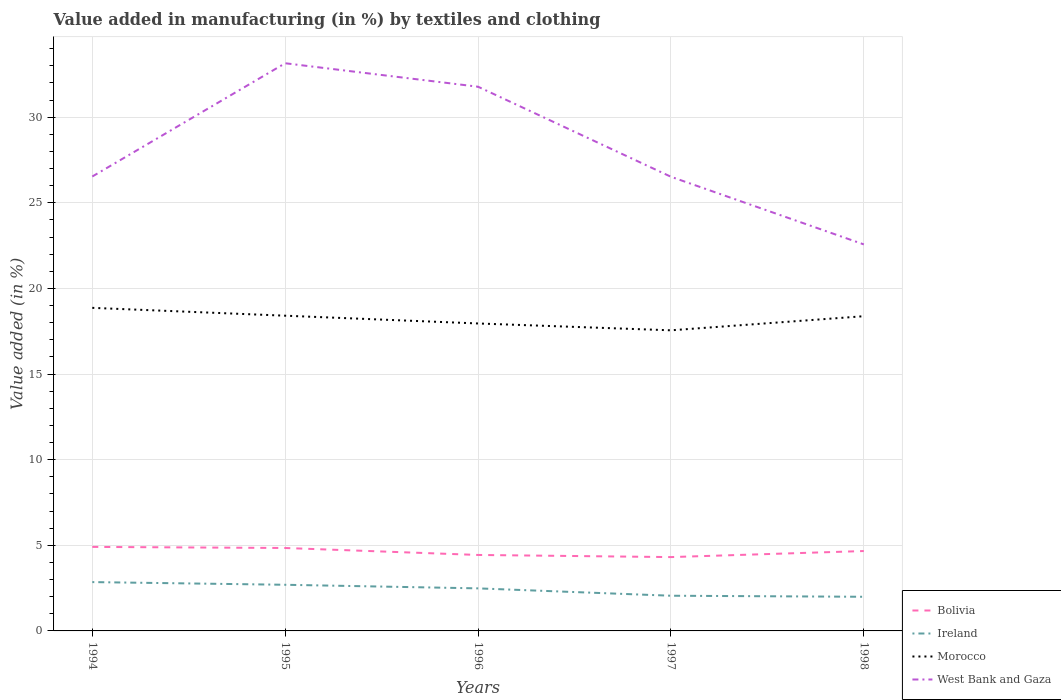How many different coloured lines are there?
Make the answer very short. 4. Does the line corresponding to Morocco intersect with the line corresponding to West Bank and Gaza?
Your answer should be compact. No. Across all years, what is the maximum percentage of value added in manufacturing by textiles and clothing in Morocco?
Keep it short and to the point. 17.56. What is the total percentage of value added in manufacturing by textiles and clothing in Bolivia in the graph?
Your answer should be very brief. 0.18. What is the difference between the highest and the second highest percentage of value added in manufacturing by textiles and clothing in Ireland?
Your answer should be compact. 0.86. What is the difference between the highest and the lowest percentage of value added in manufacturing by textiles and clothing in West Bank and Gaza?
Keep it short and to the point. 2. Is the percentage of value added in manufacturing by textiles and clothing in Bolivia strictly greater than the percentage of value added in manufacturing by textiles and clothing in Morocco over the years?
Your response must be concise. Yes. How many years are there in the graph?
Your answer should be compact. 5. What is the title of the graph?
Your answer should be very brief. Value added in manufacturing (in %) by textiles and clothing. Does "Timor-Leste" appear as one of the legend labels in the graph?
Keep it short and to the point. No. What is the label or title of the Y-axis?
Give a very brief answer. Value added (in %). What is the Value added (in %) in Bolivia in 1994?
Provide a short and direct response. 4.91. What is the Value added (in %) of Ireland in 1994?
Offer a very short reply. 2.85. What is the Value added (in %) of Morocco in 1994?
Provide a succinct answer. 18.87. What is the Value added (in %) in West Bank and Gaza in 1994?
Provide a succinct answer. 26.54. What is the Value added (in %) in Bolivia in 1995?
Your response must be concise. 4.84. What is the Value added (in %) of Ireland in 1995?
Give a very brief answer. 2.69. What is the Value added (in %) in Morocco in 1995?
Keep it short and to the point. 18.41. What is the Value added (in %) in West Bank and Gaza in 1995?
Keep it short and to the point. 33.15. What is the Value added (in %) of Bolivia in 1996?
Give a very brief answer. 4.44. What is the Value added (in %) of Ireland in 1996?
Offer a terse response. 2.49. What is the Value added (in %) in Morocco in 1996?
Make the answer very short. 17.96. What is the Value added (in %) in West Bank and Gaza in 1996?
Provide a short and direct response. 31.78. What is the Value added (in %) in Bolivia in 1997?
Provide a short and direct response. 4.31. What is the Value added (in %) in Ireland in 1997?
Give a very brief answer. 2.06. What is the Value added (in %) of Morocco in 1997?
Make the answer very short. 17.56. What is the Value added (in %) in West Bank and Gaza in 1997?
Your answer should be compact. 26.52. What is the Value added (in %) of Bolivia in 1998?
Your answer should be compact. 4.67. What is the Value added (in %) of Ireland in 1998?
Keep it short and to the point. 1.99. What is the Value added (in %) of Morocco in 1998?
Ensure brevity in your answer.  18.38. What is the Value added (in %) in West Bank and Gaza in 1998?
Your answer should be very brief. 22.57. Across all years, what is the maximum Value added (in %) of Bolivia?
Your response must be concise. 4.91. Across all years, what is the maximum Value added (in %) of Ireland?
Your answer should be compact. 2.85. Across all years, what is the maximum Value added (in %) of Morocco?
Your answer should be compact. 18.87. Across all years, what is the maximum Value added (in %) in West Bank and Gaza?
Make the answer very short. 33.15. Across all years, what is the minimum Value added (in %) in Bolivia?
Offer a very short reply. 4.31. Across all years, what is the minimum Value added (in %) of Ireland?
Your answer should be compact. 1.99. Across all years, what is the minimum Value added (in %) in Morocco?
Keep it short and to the point. 17.56. Across all years, what is the minimum Value added (in %) in West Bank and Gaza?
Provide a short and direct response. 22.57. What is the total Value added (in %) of Bolivia in the graph?
Make the answer very short. 23.16. What is the total Value added (in %) of Ireland in the graph?
Your answer should be very brief. 12.08. What is the total Value added (in %) in Morocco in the graph?
Make the answer very short. 91.17. What is the total Value added (in %) in West Bank and Gaza in the graph?
Your answer should be compact. 140.57. What is the difference between the Value added (in %) of Bolivia in 1994 and that in 1995?
Offer a terse response. 0.06. What is the difference between the Value added (in %) in Ireland in 1994 and that in 1995?
Your response must be concise. 0.16. What is the difference between the Value added (in %) in Morocco in 1994 and that in 1995?
Provide a short and direct response. 0.46. What is the difference between the Value added (in %) in West Bank and Gaza in 1994 and that in 1995?
Provide a succinct answer. -6.62. What is the difference between the Value added (in %) in Bolivia in 1994 and that in 1996?
Make the answer very short. 0.47. What is the difference between the Value added (in %) in Ireland in 1994 and that in 1996?
Ensure brevity in your answer.  0.37. What is the difference between the Value added (in %) of Morocco in 1994 and that in 1996?
Offer a terse response. 0.91. What is the difference between the Value added (in %) in West Bank and Gaza in 1994 and that in 1996?
Keep it short and to the point. -5.24. What is the difference between the Value added (in %) in Bolivia in 1994 and that in 1997?
Give a very brief answer. 0.6. What is the difference between the Value added (in %) in Ireland in 1994 and that in 1997?
Give a very brief answer. 0.8. What is the difference between the Value added (in %) in Morocco in 1994 and that in 1997?
Provide a short and direct response. 1.31. What is the difference between the Value added (in %) in West Bank and Gaza in 1994 and that in 1997?
Make the answer very short. 0.01. What is the difference between the Value added (in %) in Bolivia in 1994 and that in 1998?
Your answer should be compact. 0.24. What is the difference between the Value added (in %) in Ireland in 1994 and that in 1998?
Keep it short and to the point. 0.86. What is the difference between the Value added (in %) of Morocco in 1994 and that in 1998?
Provide a short and direct response. 0.49. What is the difference between the Value added (in %) of West Bank and Gaza in 1994 and that in 1998?
Provide a short and direct response. 3.97. What is the difference between the Value added (in %) of Bolivia in 1995 and that in 1996?
Offer a terse response. 0.41. What is the difference between the Value added (in %) in Ireland in 1995 and that in 1996?
Provide a short and direct response. 0.21. What is the difference between the Value added (in %) of Morocco in 1995 and that in 1996?
Provide a short and direct response. 0.45. What is the difference between the Value added (in %) in West Bank and Gaza in 1995 and that in 1996?
Your answer should be very brief. 1.37. What is the difference between the Value added (in %) of Bolivia in 1995 and that in 1997?
Provide a short and direct response. 0.53. What is the difference between the Value added (in %) in Ireland in 1995 and that in 1997?
Your response must be concise. 0.64. What is the difference between the Value added (in %) in Morocco in 1995 and that in 1997?
Your answer should be compact. 0.85. What is the difference between the Value added (in %) of West Bank and Gaza in 1995 and that in 1997?
Keep it short and to the point. 6.63. What is the difference between the Value added (in %) in Bolivia in 1995 and that in 1998?
Make the answer very short. 0.18. What is the difference between the Value added (in %) in Ireland in 1995 and that in 1998?
Your response must be concise. 0.7. What is the difference between the Value added (in %) of Morocco in 1995 and that in 1998?
Make the answer very short. 0.03. What is the difference between the Value added (in %) of West Bank and Gaza in 1995 and that in 1998?
Ensure brevity in your answer.  10.58. What is the difference between the Value added (in %) of Bolivia in 1996 and that in 1997?
Give a very brief answer. 0.12. What is the difference between the Value added (in %) in Ireland in 1996 and that in 1997?
Give a very brief answer. 0.43. What is the difference between the Value added (in %) of Morocco in 1996 and that in 1997?
Keep it short and to the point. 0.4. What is the difference between the Value added (in %) in West Bank and Gaza in 1996 and that in 1997?
Your response must be concise. 5.26. What is the difference between the Value added (in %) in Bolivia in 1996 and that in 1998?
Give a very brief answer. -0.23. What is the difference between the Value added (in %) of Ireland in 1996 and that in 1998?
Give a very brief answer. 0.49. What is the difference between the Value added (in %) in Morocco in 1996 and that in 1998?
Ensure brevity in your answer.  -0.42. What is the difference between the Value added (in %) of West Bank and Gaza in 1996 and that in 1998?
Your answer should be very brief. 9.21. What is the difference between the Value added (in %) in Bolivia in 1997 and that in 1998?
Provide a short and direct response. -0.35. What is the difference between the Value added (in %) of Ireland in 1997 and that in 1998?
Your answer should be very brief. 0.06. What is the difference between the Value added (in %) of Morocco in 1997 and that in 1998?
Offer a terse response. -0.82. What is the difference between the Value added (in %) of West Bank and Gaza in 1997 and that in 1998?
Ensure brevity in your answer.  3.95. What is the difference between the Value added (in %) of Bolivia in 1994 and the Value added (in %) of Ireland in 1995?
Your answer should be very brief. 2.21. What is the difference between the Value added (in %) of Bolivia in 1994 and the Value added (in %) of Morocco in 1995?
Your answer should be very brief. -13.5. What is the difference between the Value added (in %) of Bolivia in 1994 and the Value added (in %) of West Bank and Gaza in 1995?
Offer a very short reply. -28.25. What is the difference between the Value added (in %) of Ireland in 1994 and the Value added (in %) of Morocco in 1995?
Your answer should be very brief. -15.56. What is the difference between the Value added (in %) in Ireland in 1994 and the Value added (in %) in West Bank and Gaza in 1995?
Your answer should be very brief. -30.3. What is the difference between the Value added (in %) in Morocco in 1994 and the Value added (in %) in West Bank and Gaza in 1995?
Give a very brief answer. -14.28. What is the difference between the Value added (in %) in Bolivia in 1994 and the Value added (in %) in Ireland in 1996?
Provide a succinct answer. 2.42. What is the difference between the Value added (in %) in Bolivia in 1994 and the Value added (in %) in Morocco in 1996?
Your response must be concise. -13.05. What is the difference between the Value added (in %) in Bolivia in 1994 and the Value added (in %) in West Bank and Gaza in 1996?
Provide a short and direct response. -26.87. What is the difference between the Value added (in %) of Ireland in 1994 and the Value added (in %) of Morocco in 1996?
Your answer should be very brief. -15.1. What is the difference between the Value added (in %) of Ireland in 1994 and the Value added (in %) of West Bank and Gaza in 1996?
Offer a very short reply. -28.93. What is the difference between the Value added (in %) of Morocco in 1994 and the Value added (in %) of West Bank and Gaza in 1996?
Make the answer very short. -12.91. What is the difference between the Value added (in %) in Bolivia in 1994 and the Value added (in %) in Ireland in 1997?
Provide a short and direct response. 2.85. What is the difference between the Value added (in %) of Bolivia in 1994 and the Value added (in %) of Morocco in 1997?
Make the answer very short. -12.65. What is the difference between the Value added (in %) of Bolivia in 1994 and the Value added (in %) of West Bank and Gaza in 1997?
Ensure brevity in your answer.  -21.62. What is the difference between the Value added (in %) of Ireland in 1994 and the Value added (in %) of Morocco in 1997?
Keep it short and to the point. -14.7. What is the difference between the Value added (in %) of Ireland in 1994 and the Value added (in %) of West Bank and Gaza in 1997?
Your response must be concise. -23.67. What is the difference between the Value added (in %) of Morocco in 1994 and the Value added (in %) of West Bank and Gaza in 1997?
Offer a very short reply. -7.66. What is the difference between the Value added (in %) of Bolivia in 1994 and the Value added (in %) of Ireland in 1998?
Your answer should be compact. 2.91. What is the difference between the Value added (in %) in Bolivia in 1994 and the Value added (in %) in Morocco in 1998?
Give a very brief answer. -13.47. What is the difference between the Value added (in %) of Bolivia in 1994 and the Value added (in %) of West Bank and Gaza in 1998?
Your response must be concise. -17.67. What is the difference between the Value added (in %) in Ireland in 1994 and the Value added (in %) in Morocco in 1998?
Your answer should be very brief. -15.53. What is the difference between the Value added (in %) in Ireland in 1994 and the Value added (in %) in West Bank and Gaza in 1998?
Make the answer very short. -19.72. What is the difference between the Value added (in %) in Morocco in 1994 and the Value added (in %) in West Bank and Gaza in 1998?
Offer a terse response. -3.7. What is the difference between the Value added (in %) in Bolivia in 1995 and the Value added (in %) in Ireland in 1996?
Make the answer very short. 2.36. What is the difference between the Value added (in %) in Bolivia in 1995 and the Value added (in %) in Morocco in 1996?
Provide a short and direct response. -13.11. What is the difference between the Value added (in %) in Bolivia in 1995 and the Value added (in %) in West Bank and Gaza in 1996?
Offer a terse response. -26.94. What is the difference between the Value added (in %) of Ireland in 1995 and the Value added (in %) of Morocco in 1996?
Ensure brevity in your answer.  -15.26. What is the difference between the Value added (in %) of Ireland in 1995 and the Value added (in %) of West Bank and Gaza in 1996?
Provide a short and direct response. -29.09. What is the difference between the Value added (in %) in Morocco in 1995 and the Value added (in %) in West Bank and Gaza in 1996?
Provide a short and direct response. -13.37. What is the difference between the Value added (in %) of Bolivia in 1995 and the Value added (in %) of Ireland in 1997?
Keep it short and to the point. 2.79. What is the difference between the Value added (in %) of Bolivia in 1995 and the Value added (in %) of Morocco in 1997?
Offer a very short reply. -12.71. What is the difference between the Value added (in %) in Bolivia in 1995 and the Value added (in %) in West Bank and Gaza in 1997?
Offer a very short reply. -21.68. What is the difference between the Value added (in %) of Ireland in 1995 and the Value added (in %) of Morocco in 1997?
Ensure brevity in your answer.  -14.86. What is the difference between the Value added (in %) in Ireland in 1995 and the Value added (in %) in West Bank and Gaza in 1997?
Your answer should be compact. -23.83. What is the difference between the Value added (in %) in Morocco in 1995 and the Value added (in %) in West Bank and Gaza in 1997?
Provide a succinct answer. -8.11. What is the difference between the Value added (in %) of Bolivia in 1995 and the Value added (in %) of Ireland in 1998?
Make the answer very short. 2.85. What is the difference between the Value added (in %) of Bolivia in 1995 and the Value added (in %) of Morocco in 1998?
Your answer should be very brief. -13.54. What is the difference between the Value added (in %) of Bolivia in 1995 and the Value added (in %) of West Bank and Gaza in 1998?
Make the answer very short. -17.73. What is the difference between the Value added (in %) in Ireland in 1995 and the Value added (in %) in Morocco in 1998?
Offer a terse response. -15.69. What is the difference between the Value added (in %) in Ireland in 1995 and the Value added (in %) in West Bank and Gaza in 1998?
Provide a short and direct response. -19.88. What is the difference between the Value added (in %) in Morocco in 1995 and the Value added (in %) in West Bank and Gaza in 1998?
Your answer should be very brief. -4.16. What is the difference between the Value added (in %) in Bolivia in 1996 and the Value added (in %) in Ireland in 1997?
Offer a terse response. 2.38. What is the difference between the Value added (in %) in Bolivia in 1996 and the Value added (in %) in Morocco in 1997?
Give a very brief answer. -13.12. What is the difference between the Value added (in %) of Bolivia in 1996 and the Value added (in %) of West Bank and Gaza in 1997?
Ensure brevity in your answer.  -22.09. What is the difference between the Value added (in %) of Ireland in 1996 and the Value added (in %) of Morocco in 1997?
Provide a succinct answer. -15.07. What is the difference between the Value added (in %) of Ireland in 1996 and the Value added (in %) of West Bank and Gaza in 1997?
Make the answer very short. -24.04. What is the difference between the Value added (in %) in Morocco in 1996 and the Value added (in %) in West Bank and Gaza in 1997?
Provide a succinct answer. -8.57. What is the difference between the Value added (in %) in Bolivia in 1996 and the Value added (in %) in Ireland in 1998?
Your answer should be compact. 2.44. What is the difference between the Value added (in %) in Bolivia in 1996 and the Value added (in %) in Morocco in 1998?
Offer a terse response. -13.94. What is the difference between the Value added (in %) in Bolivia in 1996 and the Value added (in %) in West Bank and Gaza in 1998?
Ensure brevity in your answer.  -18.14. What is the difference between the Value added (in %) in Ireland in 1996 and the Value added (in %) in Morocco in 1998?
Make the answer very short. -15.9. What is the difference between the Value added (in %) of Ireland in 1996 and the Value added (in %) of West Bank and Gaza in 1998?
Your answer should be very brief. -20.09. What is the difference between the Value added (in %) of Morocco in 1996 and the Value added (in %) of West Bank and Gaza in 1998?
Provide a short and direct response. -4.62. What is the difference between the Value added (in %) in Bolivia in 1997 and the Value added (in %) in Ireland in 1998?
Give a very brief answer. 2.32. What is the difference between the Value added (in %) of Bolivia in 1997 and the Value added (in %) of Morocco in 1998?
Provide a short and direct response. -14.07. What is the difference between the Value added (in %) in Bolivia in 1997 and the Value added (in %) in West Bank and Gaza in 1998?
Offer a terse response. -18.26. What is the difference between the Value added (in %) in Ireland in 1997 and the Value added (in %) in Morocco in 1998?
Your answer should be compact. -16.33. What is the difference between the Value added (in %) of Ireland in 1997 and the Value added (in %) of West Bank and Gaza in 1998?
Give a very brief answer. -20.52. What is the difference between the Value added (in %) of Morocco in 1997 and the Value added (in %) of West Bank and Gaza in 1998?
Your response must be concise. -5.02. What is the average Value added (in %) of Bolivia per year?
Provide a succinct answer. 4.63. What is the average Value added (in %) of Ireland per year?
Provide a succinct answer. 2.42. What is the average Value added (in %) in Morocco per year?
Ensure brevity in your answer.  18.23. What is the average Value added (in %) in West Bank and Gaza per year?
Make the answer very short. 28.11. In the year 1994, what is the difference between the Value added (in %) of Bolivia and Value added (in %) of Ireland?
Make the answer very short. 2.06. In the year 1994, what is the difference between the Value added (in %) of Bolivia and Value added (in %) of Morocco?
Your answer should be very brief. -13.96. In the year 1994, what is the difference between the Value added (in %) in Bolivia and Value added (in %) in West Bank and Gaza?
Offer a very short reply. -21.63. In the year 1994, what is the difference between the Value added (in %) in Ireland and Value added (in %) in Morocco?
Offer a very short reply. -16.02. In the year 1994, what is the difference between the Value added (in %) in Ireland and Value added (in %) in West Bank and Gaza?
Give a very brief answer. -23.69. In the year 1994, what is the difference between the Value added (in %) in Morocco and Value added (in %) in West Bank and Gaza?
Your response must be concise. -7.67. In the year 1995, what is the difference between the Value added (in %) of Bolivia and Value added (in %) of Ireland?
Your answer should be compact. 2.15. In the year 1995, what is the difference between the Value added (in %) of Bolivia and Value added (in %) of Morocco?
Keep it short and to the point. -13.57. In the year 1995, what is the difference between the Value added (in %) of Bolivia and Value added (in %) of West Bank and Gaza?
Provide a succinct answer. -28.31. In the year 1995, what is the difference between the Value added (in %) of Ireland and Value added (in %) of Morocco?
Give a very brief answer. -15.71. In the year 1995, what is the difference between the Value added (in %) in Ireland and Value added (in %) in West Bank and Gaza?
Your answer should be compact. -30.46. In the year 1995, what is the difference between the Value added (in %) of Morocco and Value added (in %) of West Bank and Gaza?
Give a very brief answer. -14.74. In the year 1996, what is the difference between the Value added (in %) in Bolivia and Value added (in %) in Ireland?
Provide a succinct answer. 1.95. In the year 1996, what is the difference between the Value added (in %) in Bolivia and Value added (in %) in Morocco?
Keep it short and to the point. -13.52. In the year 1996, what is the difference between the Value added (in %) of Bolivia and Value added (in %) of West Bank and Gaza?
Make the answer very short. -27.35. In the year 1996, what is the difference between the Value added (in %) in Ireland and Value added (in %) in Morocco?
Provide a short and direct response. -15.47. In the year 1996, what is the difference between the Value added (in %) in Ireland and Value added (in %) in West Bank and Gaza?
Provide a short and direct response. -29.3. In the year 1996, what is the difference between the Value added (in %) in Morocco and Value added (in %) in West Bank and Gaza?
Make the answer very short. -13.83. In the year 1997, what is the difference between the Value added (in %) in Bolivia and Value added (in %) in Ireland?
Ensure brevity in your answer.  2.26. In the year 1997, what is the difference between the Value added (in %) of Bolivia and Value added (in %) of Morocco?
Offer a very short reply. -13.24. In the year 1997, what is the difference between the Value added (in %) in Bolivia and Value added (in %) in West Bank and Gaza?
Give a very brief answer. -22.21. In the year 1997, what is the difference between the Value added (in %) in Ireland and Value added (in %) in Morocco?
Your answer should be compact. -15.5. In the year 1997, what is the difference between the Value added (in %) in Ireland and Value added (in %) in West Bank and Gaza?
Provide a succinct answer. -24.47. In the year 1997, what is the difference between the Value added (in %) in Morocco and Value added (in %) in West Bank and Gaza?
Your answer should be very brief. -8.97. In the year 1998, what is the difference between the Value added (in %) in Bolivia and Value added (in %) in Ireland?
Your answer should be compact. 2.67. In the year 1998, what is the difference between the Value added (in %) in Bolivia and Value added (in %) in Morocco?
Your response must be concise. -13.71. In the year 1998, what is the difference between the Value added (in %) in Bolivia and Value added (in %) in West Bank and Gaza?
Offer a very short reply. -17.91. In the year 1998, what is the difference between the Value added (in %) in Ireland and Value added (in %) in Morocco?
Keep it short and to the point. -16.39. In the year 1998, what is the difference between the Value added (in %) in Ireland and Value added (in %) in West Bank and Gaza?
Your answer should be very brief. -20.58. In the year 1998, what is the difference between the Value added (in %) in Morocco and Value added (in %) in West Bank and Gaza?
Make the answer very short. -4.19. What is the ratio of the Value added (in %) in Bolivia in 1994 to that in 1995?
Offer a very short reply. 1.01. What is the ratio of the Value added (in %) in Ireland in 1994 to that in 1995?
Your answer should be very brief. 1.06. What is the ratio of the Value added (in %) of Morocco in 1994 to that in 1995?
Offer a terse response. 1.02. What is the ratio of the Value added (in %) in West Bank and Gaza in 1994 to that in 1995?
Make the answer very short. 0.8. What is the ratio of the Value added (in %) of Bolivia in 1994 to that in 1996?
Offer a very short reply. 1.11. What is the ratio of the Value added (in %) in Ireland in 1994 to that in 1996?
Offer a terse response. 1.15. What is the ratio of the Value added (in %) in Morocco in 1994 to that in 1996?
Ensure brevity in your answer.  1.05. What is the ratio of the Value added (in %) in West Bank and Gaza in 1994 to that in 1996?
Your answer should be compact. 0.83. What is the ratio of the Value added (in %) of Bolivia in 1994 to that in 1997?
Offer a terse response. 1.14. What is the ratio of the Value added (in %) in Ireland in 1994 to that in 1997?
Offer a very short reply. 1.39. What is the ratio of the Value added (in %) in Morocco in 1994 to that in 1997?
Provide a short and direct response. 1.07. What is the ratio of the Value added (in %) of West Bank and Gaza in 1994 to that in 1997?
Offer a very short reply. 1. What is the ratio of the Value added (in %) in Bolivia in 1994 to that in 1998?
Give a very brief answer. 1.05. What is the ratio of the Value added (in %) of Ireland in 1994 to that in 1998?
Your answer should be very brief. 1.43. What is the ratio of the Value added (in %) in Morocco in 1994 to that in 1998?
Provide a short and direct response. 1.03. What is the ratio of the Value added (in %) of West Bank and Gaza in 1994 to that in 1998?
Make the answer very short. 1.18. What is the ratio of the Value added (in %) of Bolivia in 1995 to that in 1996?
Your answer should be very brief. 1.09. What is the ratio of the Value added (in %) in Ireland in 1995 to that in 1996?
Offer a very short reply. 1.08. What is the ratio of the Value added (in %) in Morocco in 1995 to that in 1996?
Offer a terse response. 1.03. What is the ratio of the Value added (in %) of West Bank and Gaza in 1995 to that in 1996?
Your answer should be compact. 1.04. What is the ratio of the Value added (in %) of Bolivia in 1995 to that in 1997?
Your response must be concise. 1.12. What is the ratio of the Value added (in %) of Ireland in 1995 to that in 1997?
Provide a succinct answer. 1.31. What is the ratio of the Value added (in %) in Morocco in 1995 to that in 1997?
Your response must be concise. 1.05. What is the ratio of the Value added (in %) in West Bank and Gaza in 1995 to that in 1997?
Offer a terse response. 1.25. What is the ratio of the Value added (in %) of Bolivia in 1995 to that in 1998?
Offer a very short reply. 1.04. What is the ratio of the Value added (in %) of Ireland in 1995 to that in 1998?
Keep it short and to the point. 1.35. What is the ratio of the Value added (in %) of Morocco in 1995 to that in 1998?
Keep it short and to the point. 1. What is the ratio of the Value added (in %) of West Bank and Gaza in 1995 to that in 1998?
Keep it short and to the point. 1.47. What is the ratio of the Value added (in %) of Bolivia in 1996 to that in 1997?
Your answer should be compact. 1.03. What is the ratio of the Value added (in %) of Ireland in 1996 to that in 1997?
Give a very brief answer. 1.21. What is the ratio of the Value added (in %) of Morocco in 1996 to that in 1997?
Offer a very short reply. 1.02. What is the ratio of the Value added (in %) in West Bank and Gaza in 1996 to that in 1997?
Give a very brief answer. 1.2. What is the ratio of the Value added (in %) of Bolivia in 1996 to that in 1998?
Offer a very short reply. 0.95. What is the ratio of the Value added (in %) of Ireland in 1996 to that in 1998?
Your response must be concise. 1.25. What is the ratio of the Value added (in %) of Morocco in 1996 to that in 1998?
Your answer should be very brief. 0.98. What is the ratio of the Value added (in %) in West Bank and Gaza in 1996 to that in 1998?
Keep it short and to the point. 1.41. What is the ratio of the Value added (in %) in Bolivia in 1997 to that in 1998?
Offer a very short reply. 0.92. What is the ratio of the Value added (in %) of Ireland in 1997 to that in 1998?
Your response must be concise. 1.03. What is the ratio of the Value added (in %) in Morocco in 1997 to that in 1998?
Make the answer very short. 0.96. What is the ratio of the Value added (in %) of West Bank and Gaza in 1997 to that in 1998?
Provide a short and direct response. 1.18. What is the difference between the highest and the second highest Value added (in %) in Bolivia?
Offer a very short reply. 0.06. What is the difference between the highest and the second highest Value added (in %) of Ireland?
Provide a succinct answer. 0.16. What is the difference between the highest and the second highest Value added (in %) of Morocco?
Give a very brief answer. 0.46. What is the difference between the highest and the second highest Value added (in %) in West Bank and Gaza?
Ensure brevity in your answer.  1.37. What is the difference between the highest and the lowest Value added (in %) of Bolivia?
Make the answer very short. 0.6. What is the difference between the highest and the lowest Value added (in %) in Ireland?
Your answer should be very brief. 0.86. What is the difference between the highest and the lowest Value added (in %) of Morocco?
Provide a succinct answer. 1.31. What is the difference between the highest and the lowest Value added (in %) of West Bank and Gaza?
Ensure brevity in your answer.  10.58. 